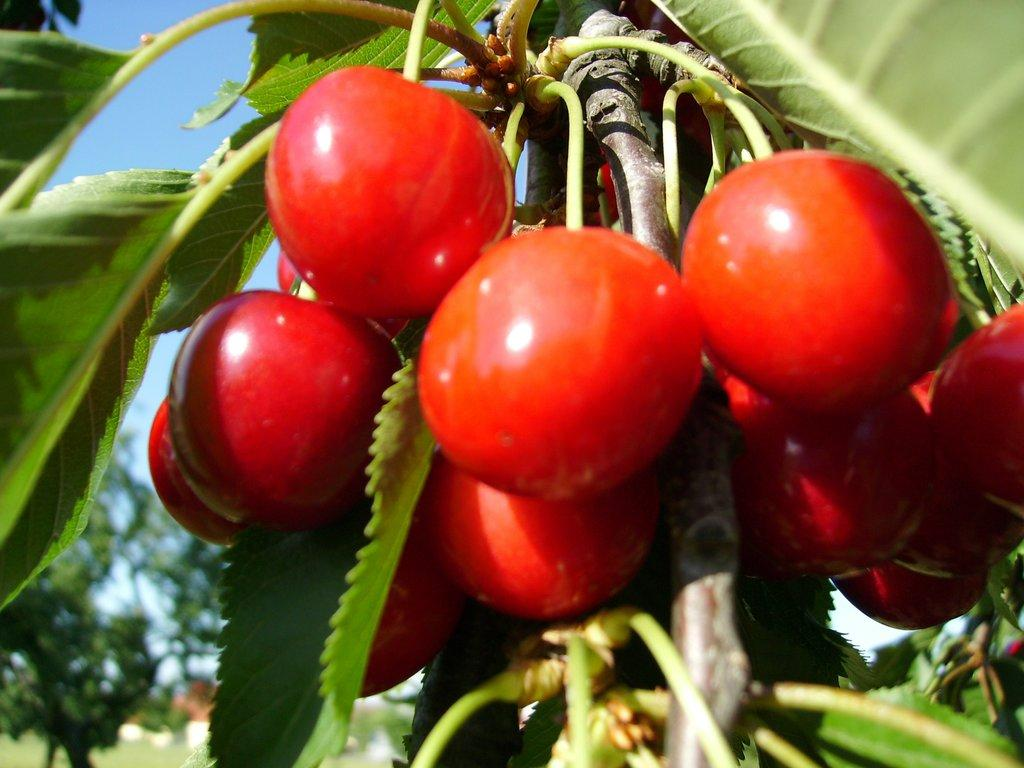What type of fruit can be seen on the tree in the image? There are cherries on a tree in the image. What else can be seen in the background of the image? There are trees visible in the background of the image. What is visible at the top of the image? The sky is visible at the top of the image. Can you read the letters on the stream in the image? There is no stream present in the image, and therefore no letters to read. 